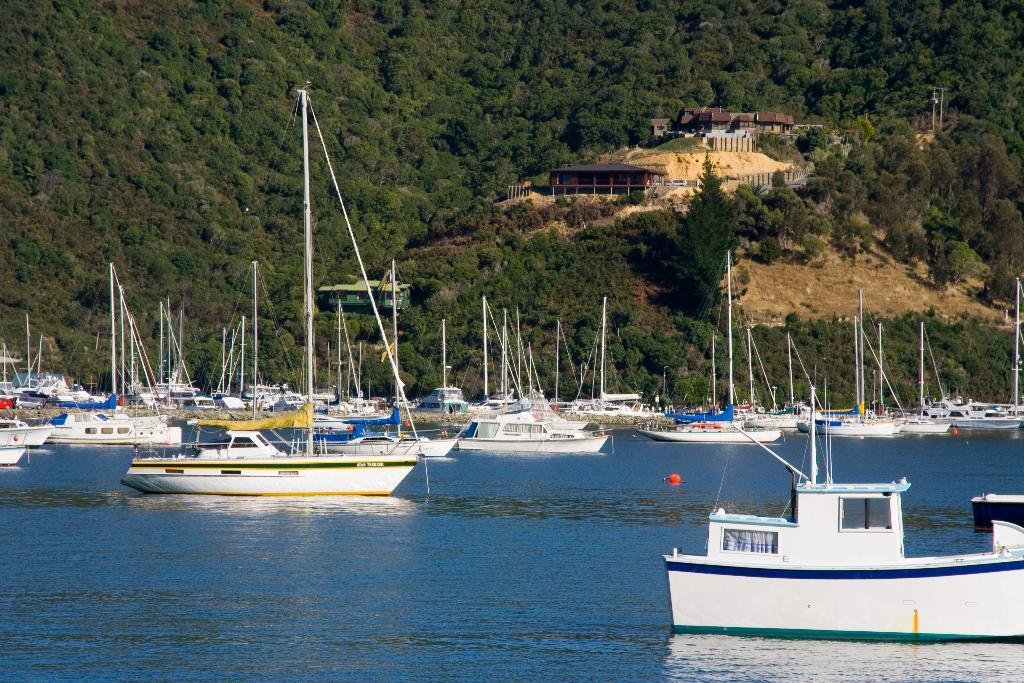What is the main subject in the center of the image? There are ships in the center of the image. What is located at the bottom of the image? There is water at the bottom of the image. What can be seen in the background of the image? There are trees and houses in the background of the image. What type of bread can be seen floating on the water in the image? There is no bread present in the image; it features ships on water with trees and houses in the background. 